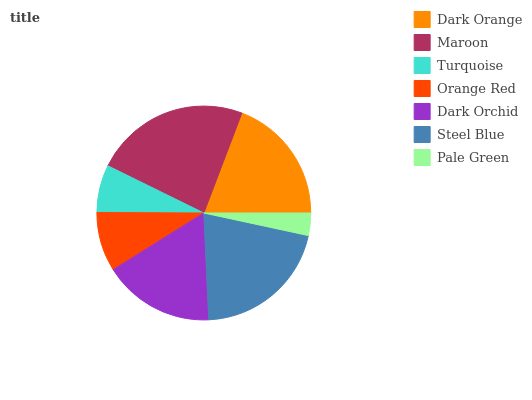Is Pale Green the minimum?
Answer yes or no. Yes. Is Maroon the maximum?
Answer yes or no. Yes. Is Turquoise the minimum?
Answer yes or no. No. Is Turquoise the maximum?
Answer yes or no. No. Is Maroon greater than Turquoise?
Answer yes or no. Yes. Is Turquoise less than Maroon?
Answer yes or no. Yes. Is Turquoise greater than Maroon?
Answer yes or no. No. Is Maroon less than Turquoise?
Answer yes or no. No. Is Dark Orchid the high median?
Answer yes or no. Yes. Is Dark Orchid the low median?
Answer yes or no. Yes. Is Orange Red the high median?
Answer yes or no. No. Is Dark Orange the low median?
Answer yes or no. No. 